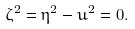<formula> <loc_0><loc_0><loc_500><loc_500>\zeta ^ { 2 } = \eta ^ { 2 } - u ^ { 2 } = 0 .</formula> 